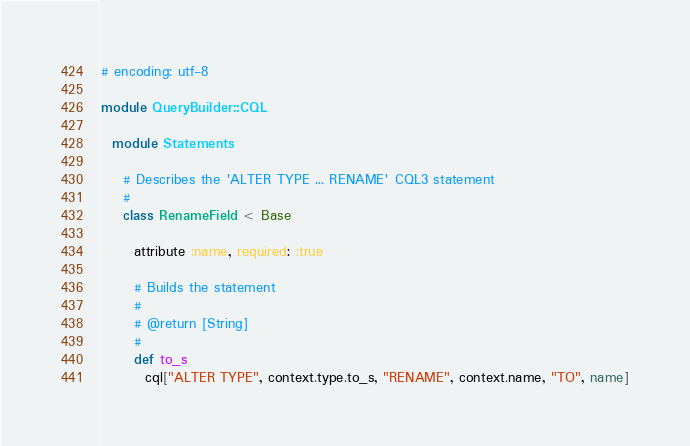Convert code to text. <code><loc_0><loc_0><loc_500><loc_500><_Ruby_># encoding: utf-8

module QueryBuilder::CQL

  module Statements

    # Describes the 'ALTER TYPE ... RENAME' CQL3 statement
    #
    class RenameField < Base

      attribute :name, required: :true

      # Builds the statement
      #
      # @return [String]
      #
      def to_s
        cql["ALTER TYPE", context.type.to_s, "RENAME", context.name, "TO", name]</code> 